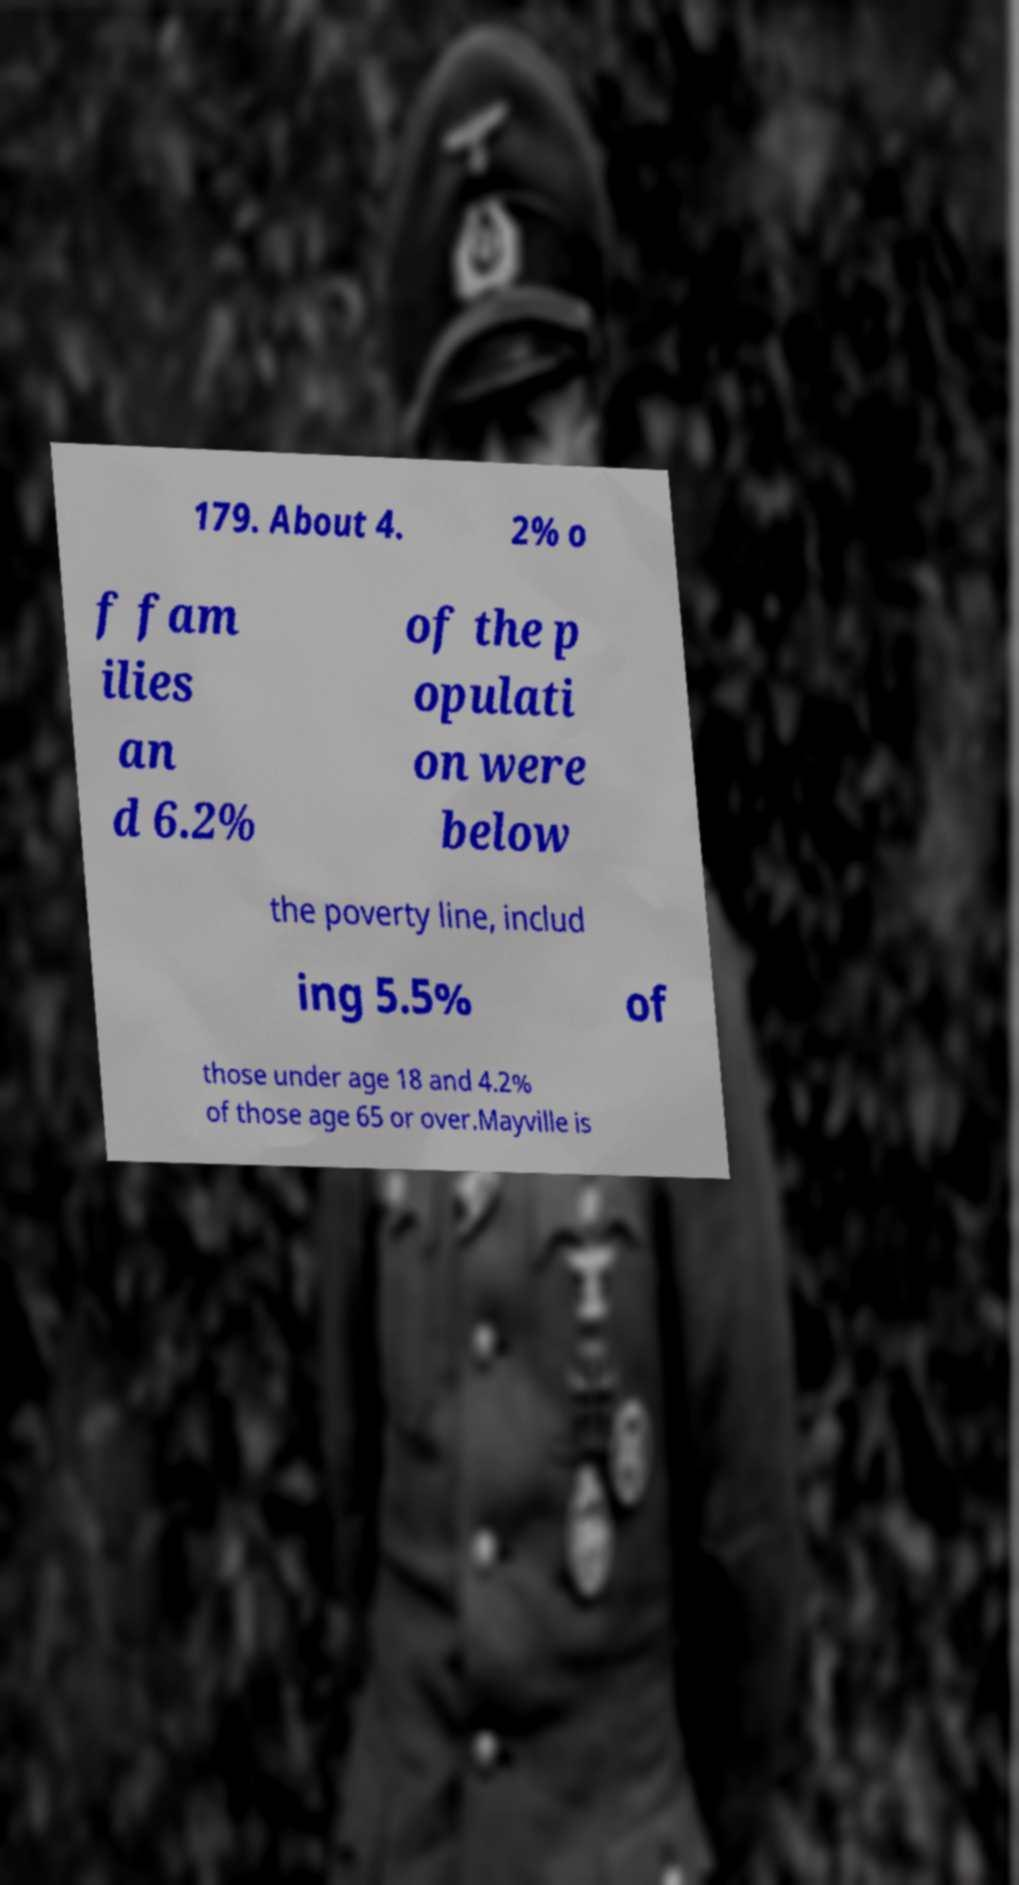Please read and relay the text visible in this image. What does it say? 179. About 4. 2% o f fam ilies an d 6.2% of the p opulati on were below the poverty line, includ ing 5.5% of those under age 18 and 4.2% of those age 65 or over.Mayville is 